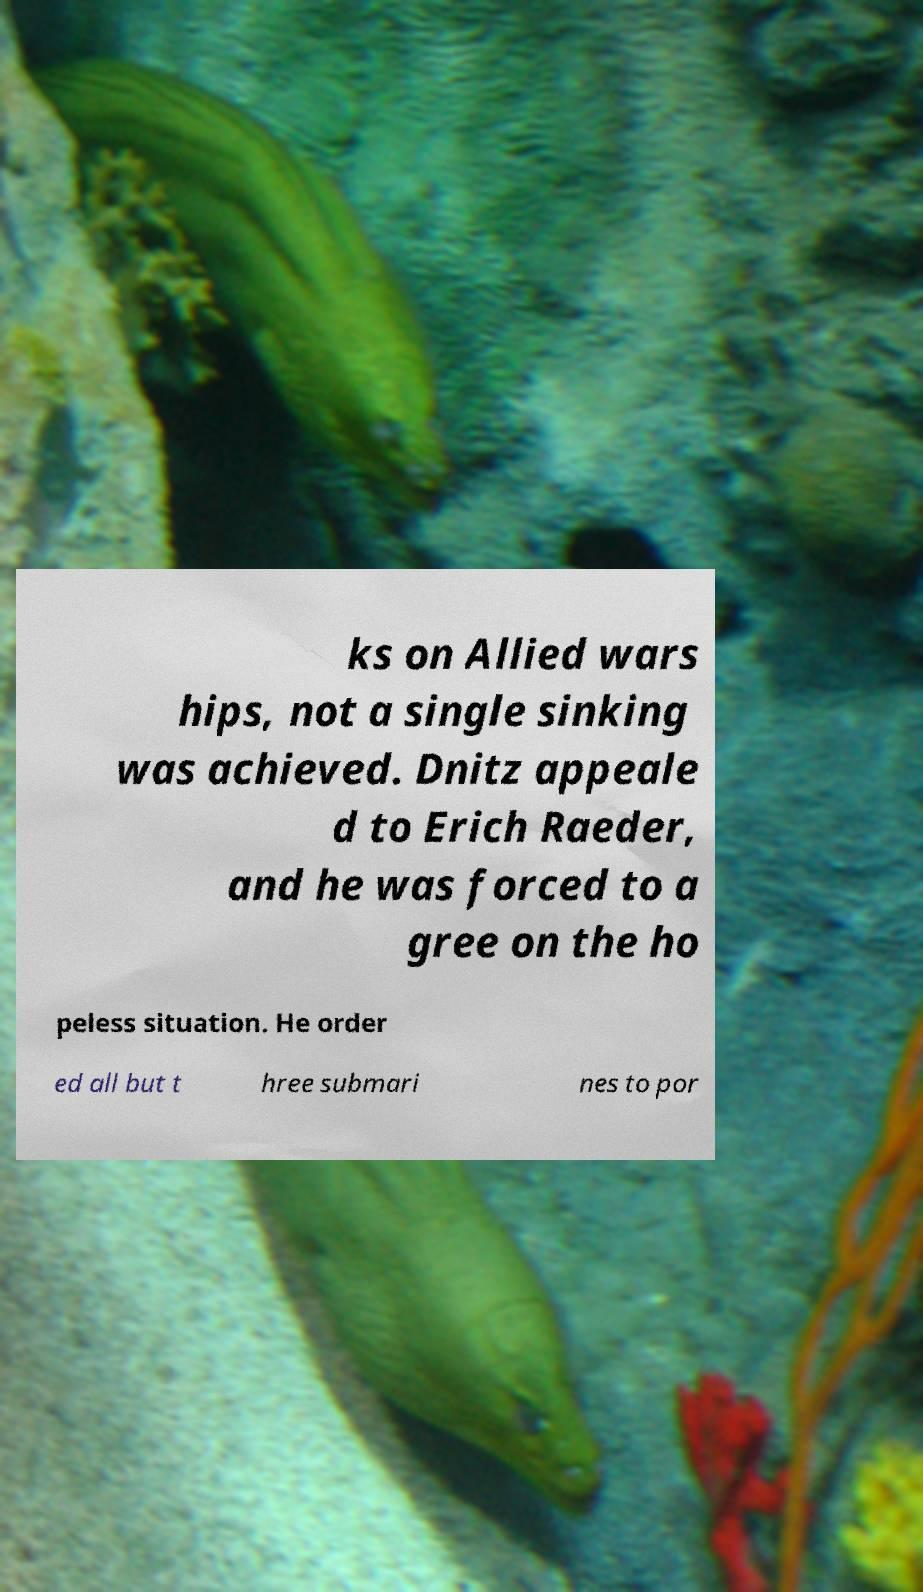Can you read and provide the text displayed in the image?This photo seems to have some interesting text. Can you extract and type it out for me? ks on Allied wars hips, not a single sinking was achieved. Dnitz appeale d to Erich Raeder, and he was forced to a gree on the ho peless situation. He order ed all but t hree submari nes to por 